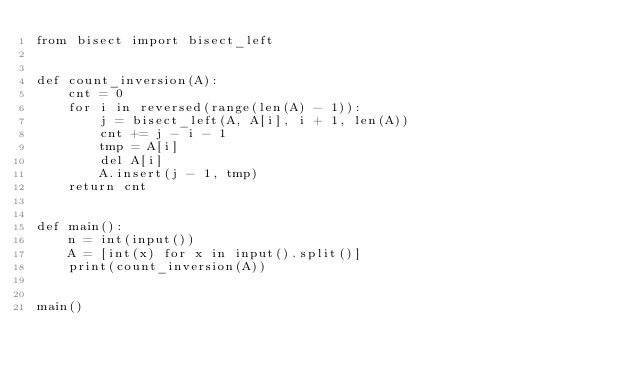Convert code to text. <code><loc_0><loc_0><loc_500><loc_500><_Python_>from bisect import bisect_left


def count_inversion(A):
    cnt = 0
    for i in reversed(range(len(A) - 1)):
        j = bisect_left(A, A[i], i + 1, len(A))
        cnt += j - i - 1
        tmp = A[i]
        del A[i]
        A.insert(j - 1, tmp)
    return cnt


def main():
    n = int(input())
    A = [int(x) for x in input().split()]
    print(count_inversion(A))


main()

</code> 